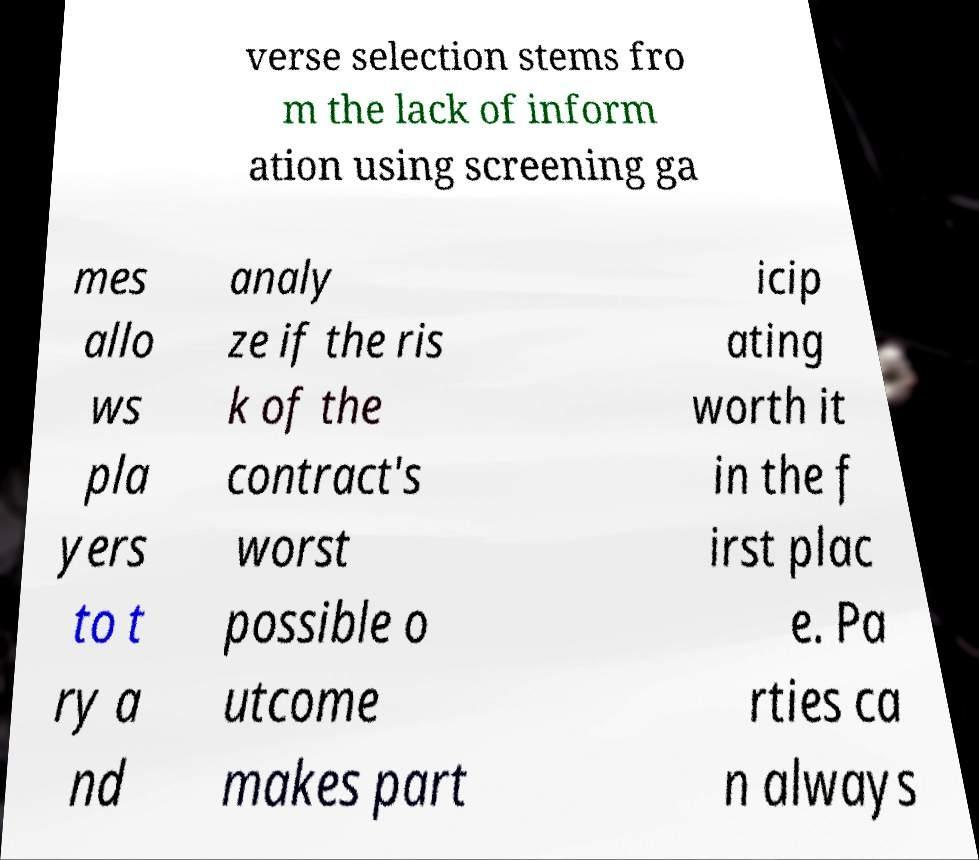Could you extract and type out the text from this image? verse selection stems fro m the lack of inform ation using screening ga mes allo ws pla yers to t ry a nd analy ze if the ris k of the contract's worst possible o utcome makes part icip ating worth it in the f irst plac e. Pa rties ca n always 